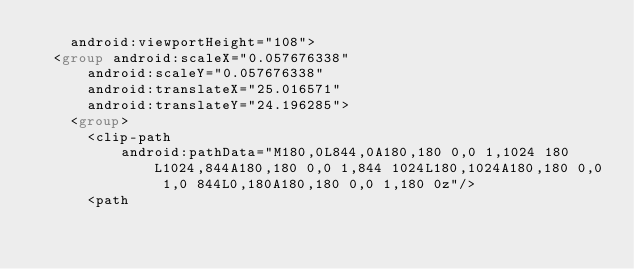Convert code to text. <code><loc_0><loc_0><loc_500><loc_500><_XML_>    android:viewportHeight="108">
  <group android:scaleX="0.057676338"
      android:scaleY="0.057676338"
      android:translateX="25.016571"
      android:translateY="24.196285">
    <group>
      <clip-path
          android:pathData="M180,0L844,0A180,180 0,0 1,1024 180L1024,844A180,180 0,0 1,844 1024L180,1024A180,180 0,0 1,0 844L0,180A180,180 0,0 1,180 0z"/>
      <path</code> 